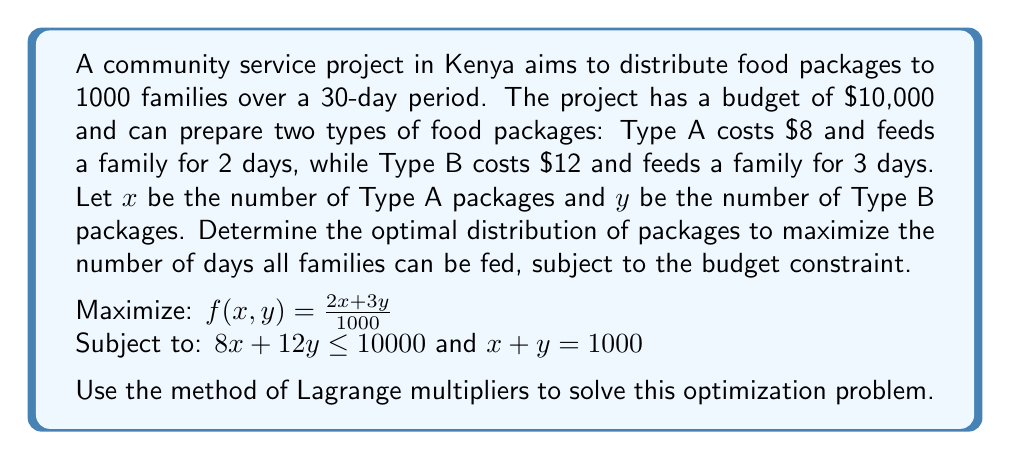Help me with this question. Let's approach this step-by-step using the method of Lagrange multipliers:

1) First, we set up the Lagrangian function:
   $$ L(x,y,\lambda,\mu) = \frac{2x + 3y}{1000} - \lambda(8x + 12y - 10000) - \mu(x + y - 1000) $$

2) Now, we take partial derivatives and set them equal to zero:
   $$ \frac{\partial L}{\partial x} = \frac{2}{1000} - 8\lambda - \mu = 0 $$
   $$ \frac{\partial L}{\partial y} = \frac{3}{1000} - 12\lambda - \mu = 0 $$
   $$ \frac{\partial L}{\partial \lambda} = 8x + 12y - 10000 = 0 $$
   $$ \frac{\partial L}{\partial \mu} = x + y - 1000 = 0 $$

3) From the first two equations:
   $$ \frac{2}{1000} - 8\lambda = \mu $$
   $$ \frac{3}{1000} - 12\lambda = \mu $$

4) Equating these:
   $$ \frac{2}{1000} - 8\lambda = \frac{3}{1000} - 12\lambda $$
   $$ 4\lambda = \frac{1}{1000} $$
   $$ \lambda = \frac{1}{4000} $$

5) Substituting this back:
   $$ \mu = \frac{2}{1000} - 8(\frac{1}{4000}) = \frac{1}{1000} $$

6) Now we have four equations with four unknowns. Solving the system:
   $$ 8x + 12y = 10000 $$
   $$ x + y = 1000 $$

7) Subtracting 8 times the second equation from the first:
   $$ 4y = 2000 $$
   $$ y = 500 $$

8) Substituting back:
   $$ x = 1000 - 500 = 500 $$

9) To verify the budget constraint:
   $$ 8(500) + 12(500) = 4000 + 6000 = 10000 $$

10) The maximum number of days all families can be fed:
    $$ f(500,500) = \frac{2(500) + 3(500)}{1000} = 2.5 \text{ days} $$
Answer: 500 Type A packages and 500 Type B packages, feeding all families for 2.5 days. 